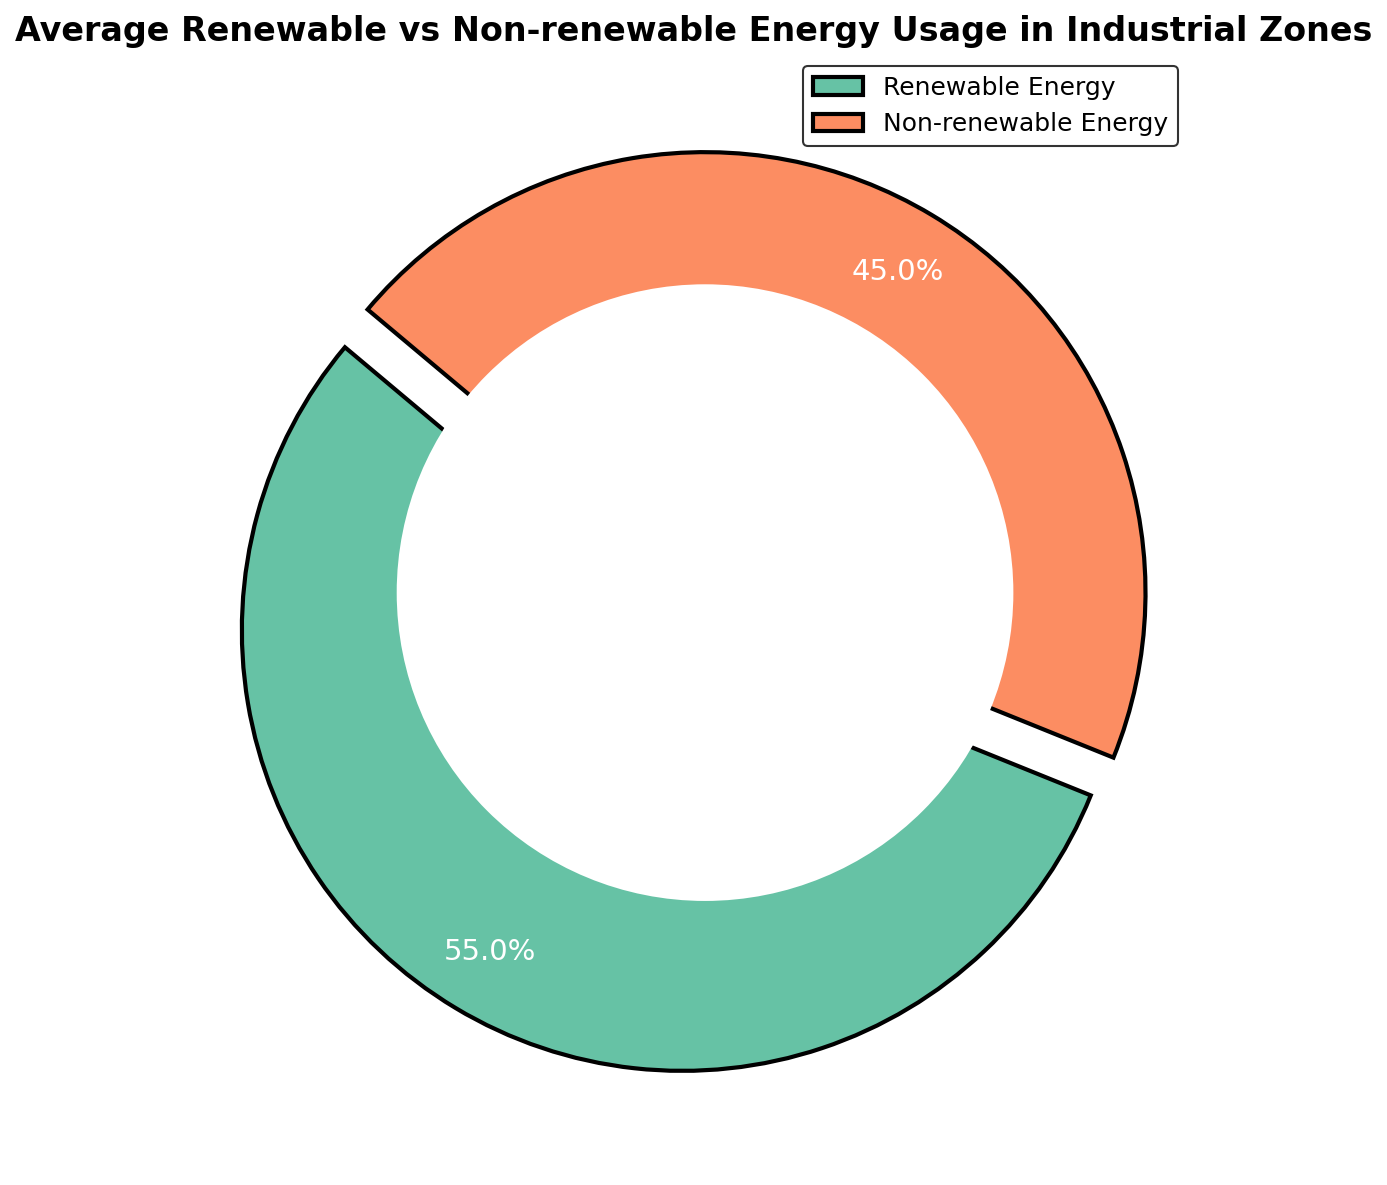How is the proportion of renewable energy usage compared to non-renewable energy usage on average? The pie chart shows two segments, one for renewable energy and one for non-renewable energy. The renewable energy segment represents 45.0%, and the non-renewable energy segment represents 55.0%. By comparing these two values, we can see that the proportion of renewable energy usage is less than that of non-renewable energy usage.
Answer: Renewable energy usage is less than non-renewable energy usage What color is used to represent renewable energy in the pie chart? The pie chart uses distinct colors for each energy type. Renewable energy is represented by green color, which is visually distinct from the color for non-renewable energy.
Answer: Green Which segment of the chart is larger, renewable or non-renewable energy? The pie chart shows two segments with their proportions. The non-renewable energy segment is 55.0%, which is larger than the renewable energy segment at 45.0%. By comparing these two percentages, we can conclude that the non-renewable energy segment is larger.
Answer: Non-renewable energy By how many percentage points is non-renewable energy usage greater than renewable energy usage? To find the difference in usage, we subtract the percentage of renewable energy (45.0%) from the percentage of non-renewable energy (55.0%). This gives us a difference of 10 percentage points.
Answer: 10 percentage points What is the significance of the circle at the center of the pie chart? The circle at the center of the pie chart creates a donut chart effect. This design choice helps in focusing on the proportions of the segments while providing a clear and engaging visual representation.
Answer: It creates a donut chart effect Could you identify the energy type that explodes out in the pie chart? The pie chart uses an explode feature to emphasize one of the segments. By examining the chart, we see that the renewable energy segment is slightly separated from the rest of the chart, indicating that it explodes out.
Answer: Renewable energy What mathematical operation is used to determine the percentages shown in the chart? The percentages in the chart are derived through the averaging operation. Each energy type's percentages are averaged over multiple data points to display the mean proportion in the pie chart.
Answer: Averaging What percentage is illustrated for each energy type in the pie chart? The pie chart displays the mean percentages of each energy type. For renewable energy, it shows 45.0%, and for non-renewable energy, it shows 55.0%, indicating their average usage in industrial zones.
Answer: Renewable: 45.0%, Non-renewable: 55.0% Why are some segments of the chart thicker in outline compared to others? The pie chart is designed with thicker outlines for all segments to provide a clear distinction between the categories. This thick outline enhances visual separation and makes the chart easier to interpret.
Answer: For visual clarity and distinction 